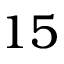Convert formula to latex. <formula><loc_0><loc_0><loc_500><loc_500>1 5</formula> 